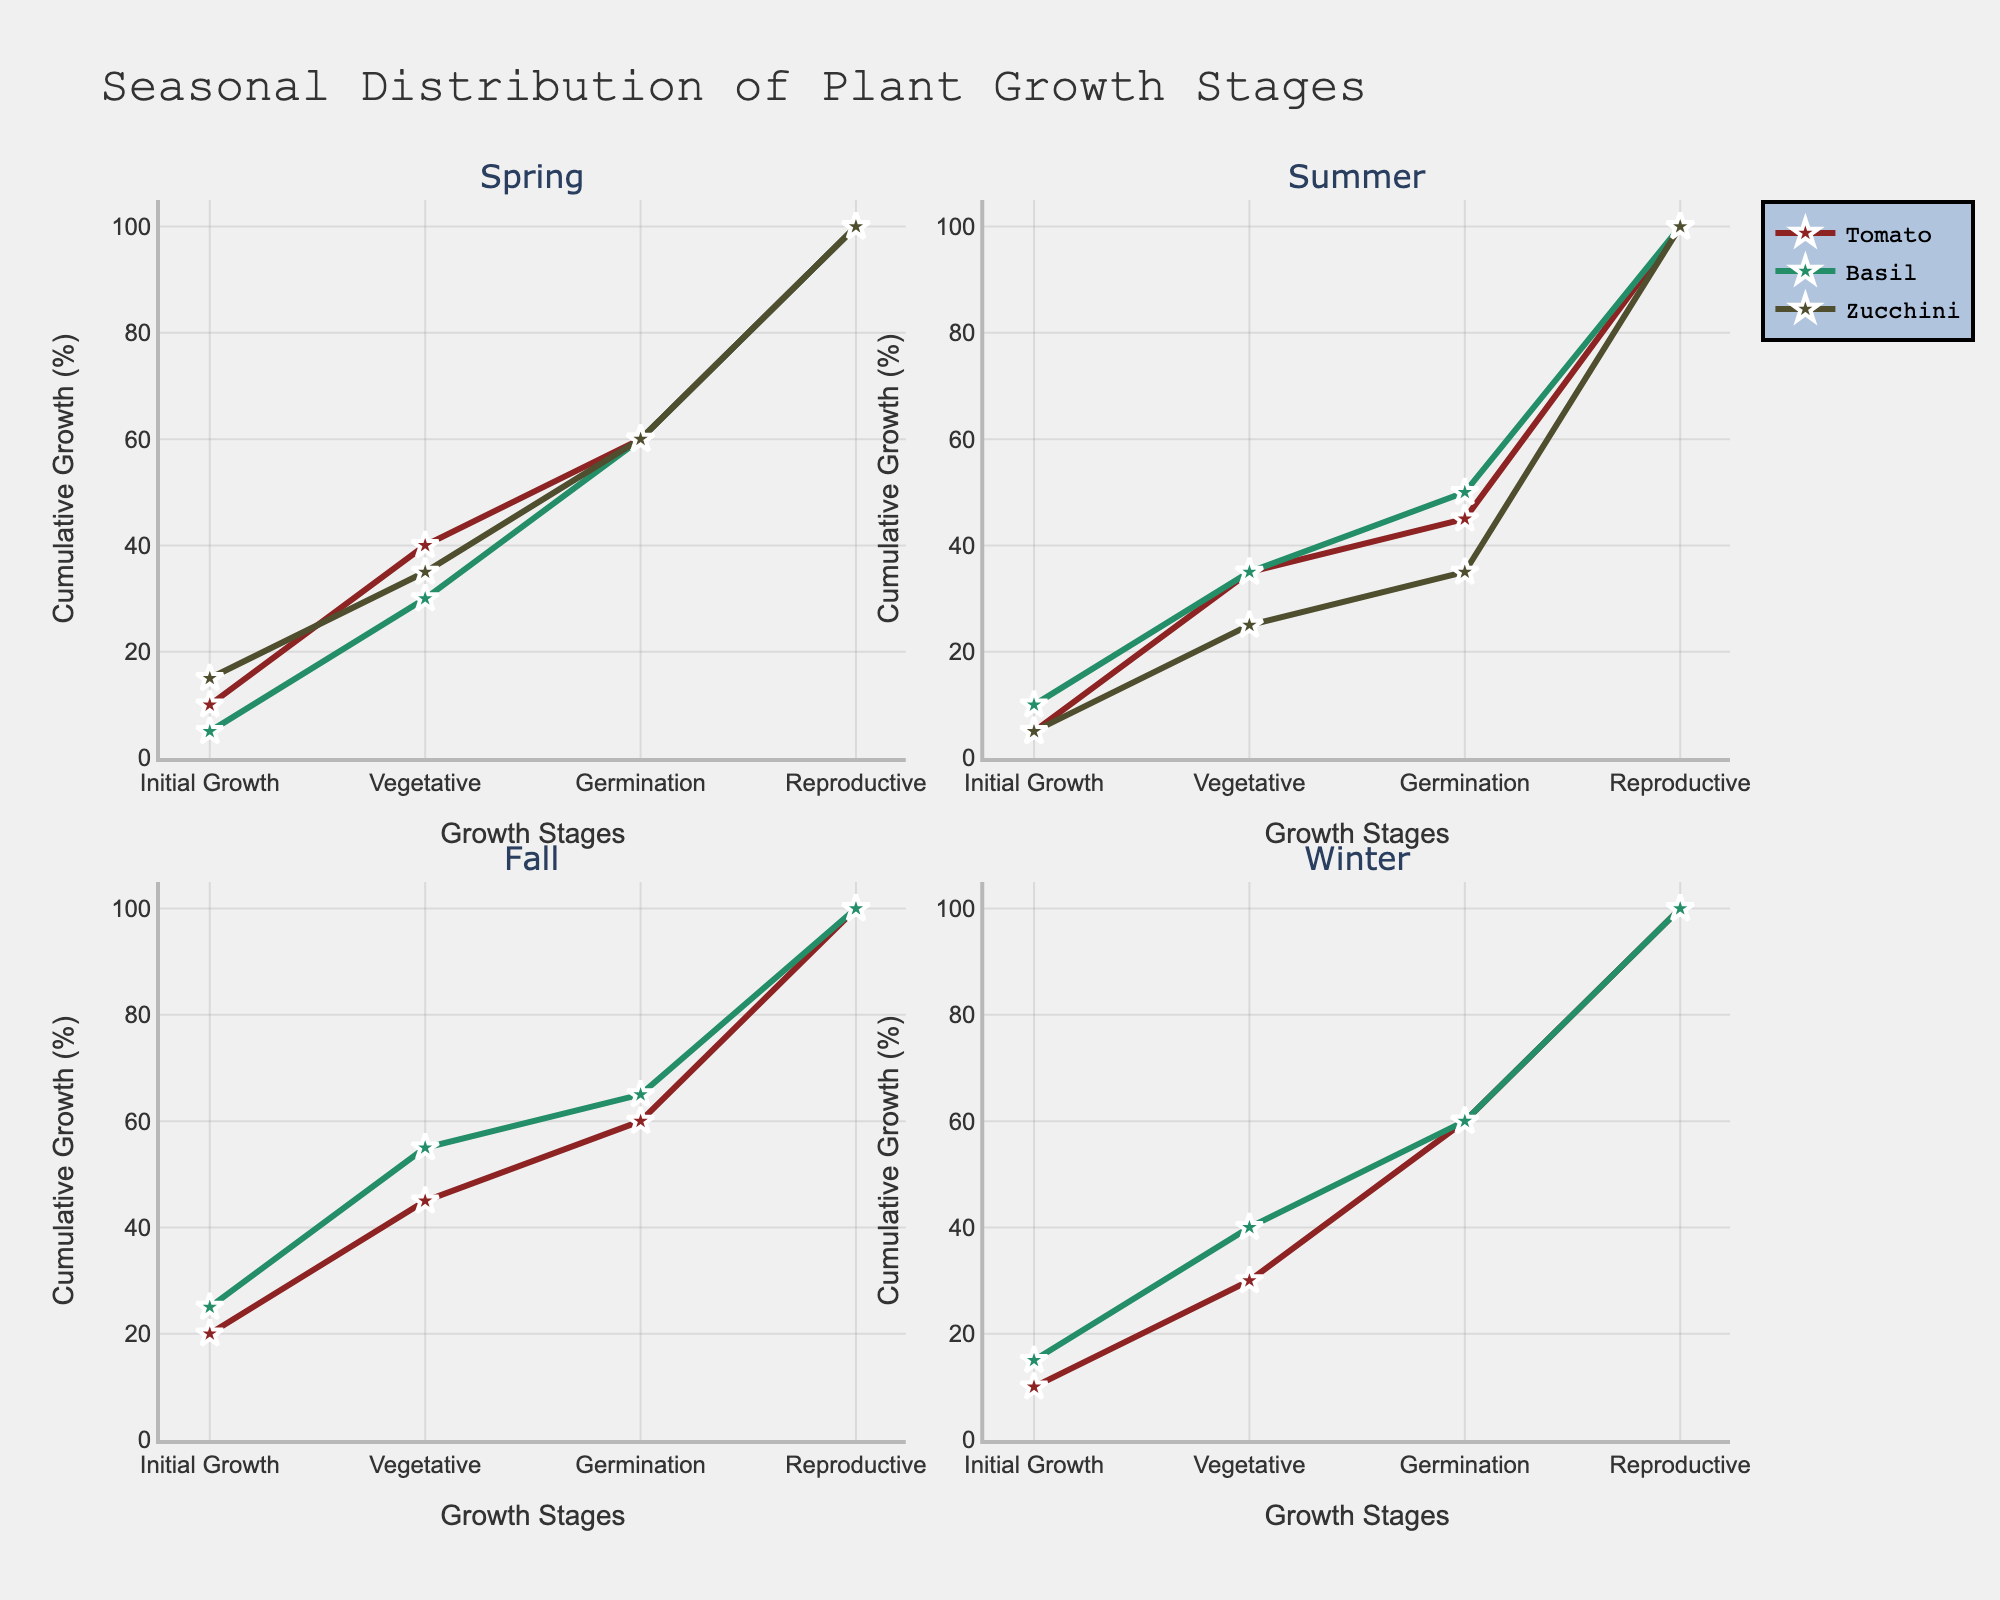What is the title of the figure? The title is typically located at the top center of the figure, and it gives a summary of what the figure is about. In this case, it indicates the subject as "Seasonal Distribution of Plant Growth Stages".
Answer: Seasonal Distribution of Plant Growth Stages What are the growth stages labeled on the x-axis? The x-axis represents the different stages of plant growth, which are indicated by textual labels. These labels appear as: "Initial Growth", "Vegetative", "Germination", and "Reproductive".
Answer: Initial Growth, Vegetative, Germination, Reproductive Which plant in summer shows the highest cumulative growth by the end of the reproductive stage? To determine this, look at the cumulative values at the end of the reproductive stage for each plant in the summer subplot. The plant with the highest endpoint value is identified. In this case, it's the Basil plant with a cumulative growth reaching the 100% mark.
Answer: Basil During which season does each subplot experience the maximum cumulative growth? Examine each of the four subplots for the season displayed and check where the highest cumulative value at the reproductive stage lies. The detailed analysis reveals maximum cumulative growth across all subplots at approximately 100% for the Reproductive stage during Summer, for Basil and Tomato plants.
Answer: Summer Compare the initial growth stage of Zucchini in spring and Cucumber in summer. Which one is higher? Identifying cumulative growth at the initial growth stage involves comparing the values at this stage in two specific subplots. For Zucchini in spring, it is 15%, and for Cucumber in summer, it is 10%. Thus, Zucchini in spring has a higher initial growth.
Answer: Zucchini in spring What is the median cumulative growth of Brussels Sprouts during fall stages? To find the median cumulative growth: 1) Note the values at the Initial Growth, Vegetative, Germination, and Reproductive stages (25, 55, 65, 100). 2) Arrange these values: [25, 55, 65, 100]. 3) The median value is the average of the second and third values ((55 + 65)/2 = 60).
Answer: 60 How does the cumulative growth of kale during fall compare to spinach during winter by the vegetative growth stage? By examining the vegetative stage values for both Kale and Spinach in their respective subplots, we compare Kale's cumulative growth (20% + 25% = 45%) with Spinach's cumulative growth (15% + 25% = 40%), indicating Kale has slightly higher cumulative growth.
Answer: Kale Identify whether any plant has achieved exactly 50% cumulative growth at any stage? By examining cumulative values in each stage for all subplots, it is found that no plant records a cumulative value of exactly 50% at any stage without further plot analysis.
Answer: No Which season and plant shows just the highest increment from the vegetative stage to the germination stage? Look for the highest difference between cumulative values at the vegetative and germination stages across all subplots. Basil in Spring shows the highest growth rise from 30% to 60%, an increment of 30%.
Answer: Basil in Spring 